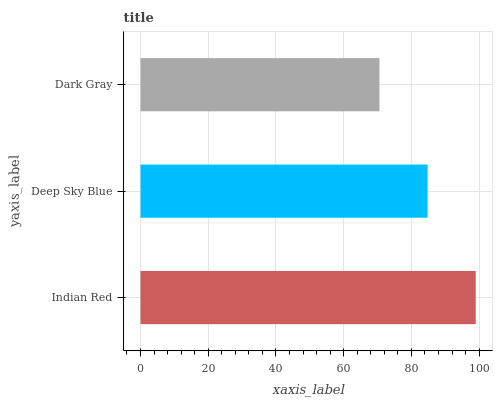Is Dark Gray the minimum?
Answer yes or no. Yes. Is Indian Red the maximum?
Answer yes or no. Yes. Is Deep Sky Blue the minimum?
Answer yes or no. No. Is Deep Sky Blue the maximum?
Answer yes or no. No. Is Indian Red greater than Deep Sky Blue?
Answer yes or no. Yes. Is Deep Sky Blue less than Indian Red?
Answer yes or no. Yes. Is Deep Sky Blue greater than Indian Red?
Answer yes or no. No. Is Indian Red less than Deep Sky Blue?
Answer yes or no. No. Is Deep Sky Blue the high median?
Answer yes or no. Yes. Is Deep Sky Blue the low median?
Answer yes or no. Yes. Is Indian Red the high median?
Answer yes or no. No. Is Indian Red the low median?
Answer yes or no. No. 